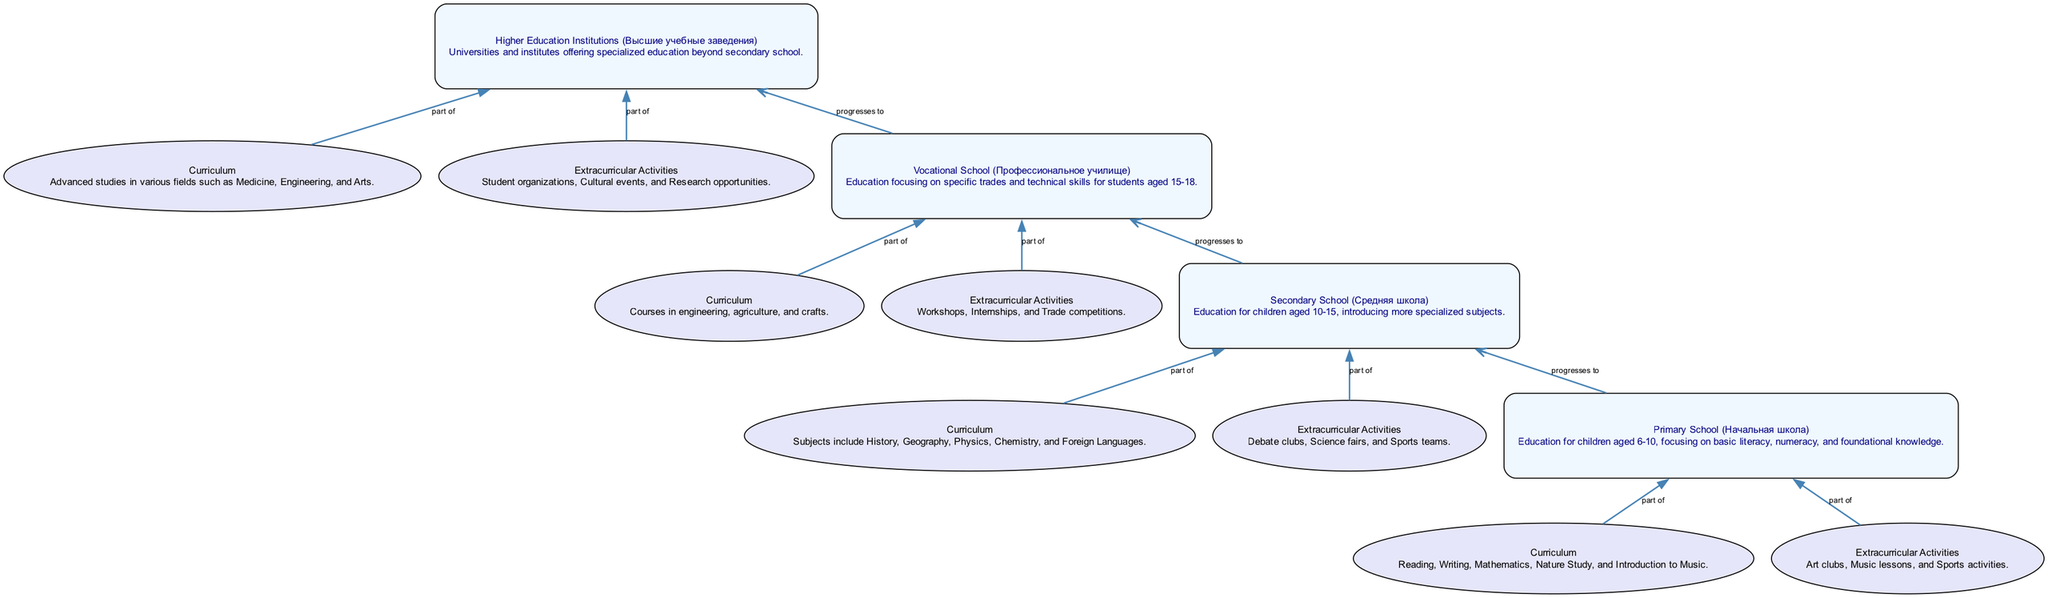What is the age range for Primary School? The diagram indicates that Primary School (Начальная школа) caters to children aged 6-10. This information can be found in the description section of the Primary School node.
Answer: 6-10 How many types of schools are mentioned in the diagram? There are four types of schools listed in the diagram: Primary School, Secondary School, Vocational School, and Higher Education Institutions. This count can be easily seen by listing out the main elements in the diagram.
Answer: 4 Which extracurricular activity is associated with Secondary School? The sub-elements under Secondary School list Debate clubs, Science fairs, and Sports teams as its extracurricular activities. This specific node can be found under the Secondary School section of the diagram.
Answer: Debate clubs What subject is NOT included in the curriculum of Primary School? The curriculum for Primary School includes Reading, Writing, Mathematics, Nature Study, and Introduction to Music. The absence of subjects like History, Geography, or Foreign Languages implies these are not part of the Primary School curriculum.
Answer: History What is the educational focus of Vocational School? The Vocational School (Профессиональное училище) is focused on specific trades and technical skills. This information is provided in the description corresponding to the Vocational School node.
Answer: Technical skills Which type of school progresses to Higher Education Institutions? The diagram shows that the progression leading to Higher Education Institutions goes from Vocational School. This is indicated by the directional edge between these two nodes.
Answer: Vocational School How many extracurricular activities are linked to Higher Education Institutions? The Higher Education Institutions offer several extracurricular activities, including Student organizations, Cultural events, and Research opportunities, totaling three activities as indicated in the sub-element section of the diagram.
Answer: 3 What subjects are introduced in Secondary School? The subjects introduced in Secondary School include History, Geography, Physics, Chemistry, and Foreign Languages, as specified in the curriculum sub-element shown in the diagram.
Answer: History, Geography, Physics, Chemistry, Foreign Languages What is the relationship between the Vocational School and the curriculum? The curriculum of the Vocational School consists of courses in engineering, agriculture, and crafts. The diagram shows this connection through a sub-node that describes vocational-specific education.
Answer: Courses in engineering, agriculture, and crafts 